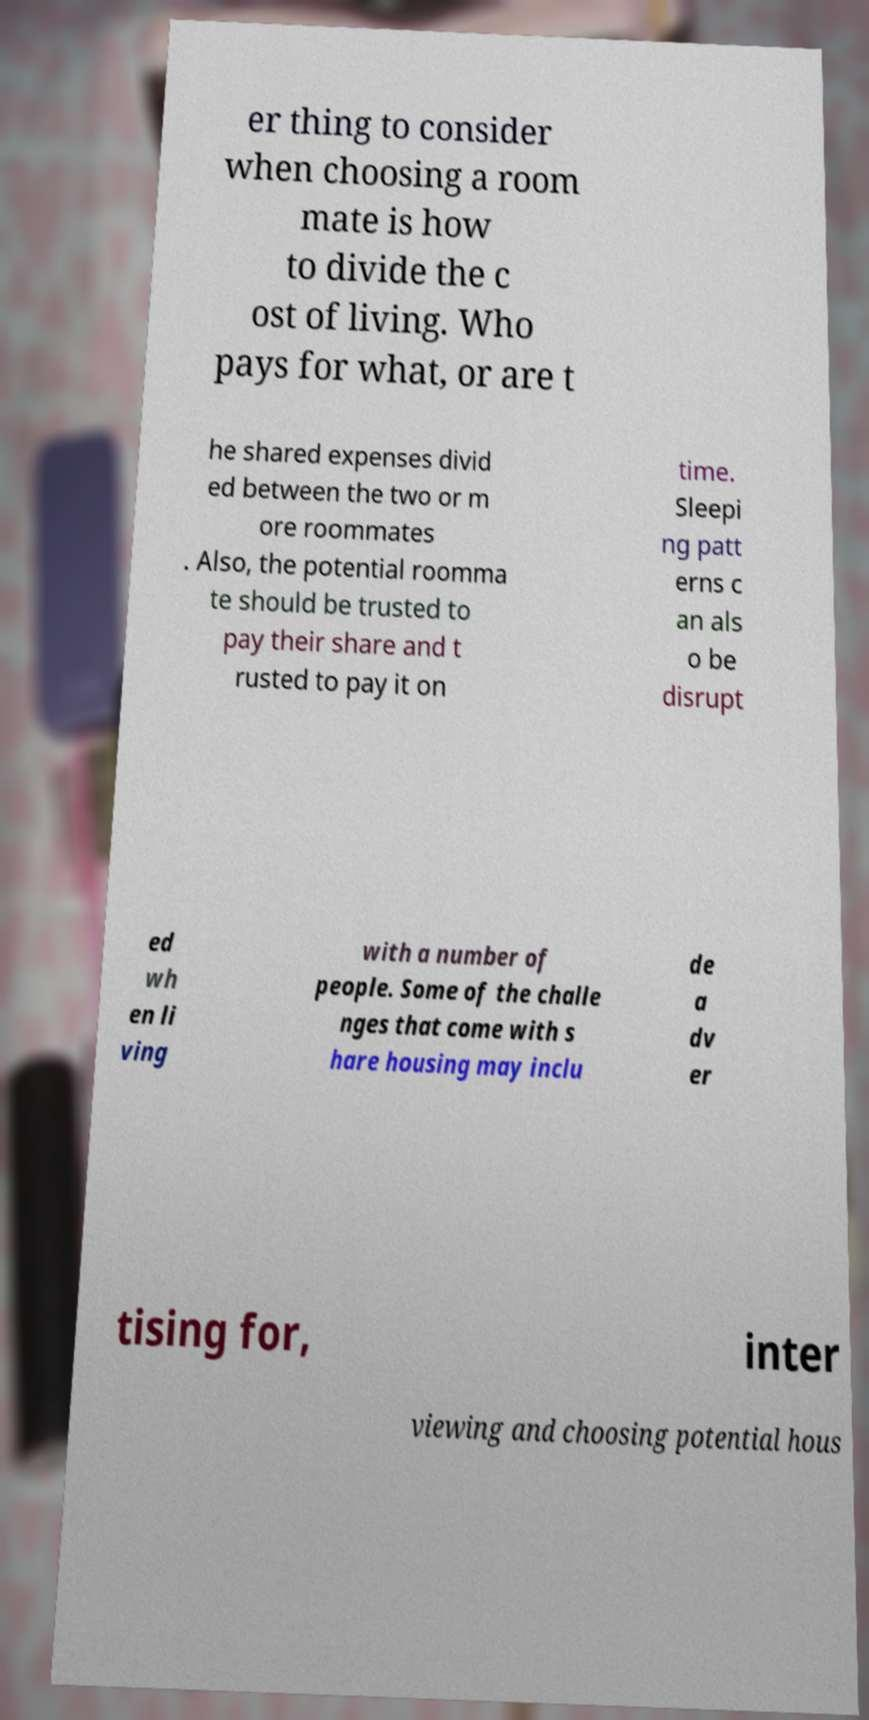What messages or text are displayed in this image? I need them in a readable, typed format. er thing to consider when choosing a room mate is how to divide the c ost of living. Who pays for what, or are t he shared expenses divid ed between the two or m ore roommates . Also, the potential roomma te should be trusted to pay their share and t rusted to pay it on time. Sleepi ng patt erns c an als o be disrupt ed wh en li ving with a number of people. Some of the challe nges that come with s hare housing may inclu de a dv er tising for, inter viewing and choosing potential hous 